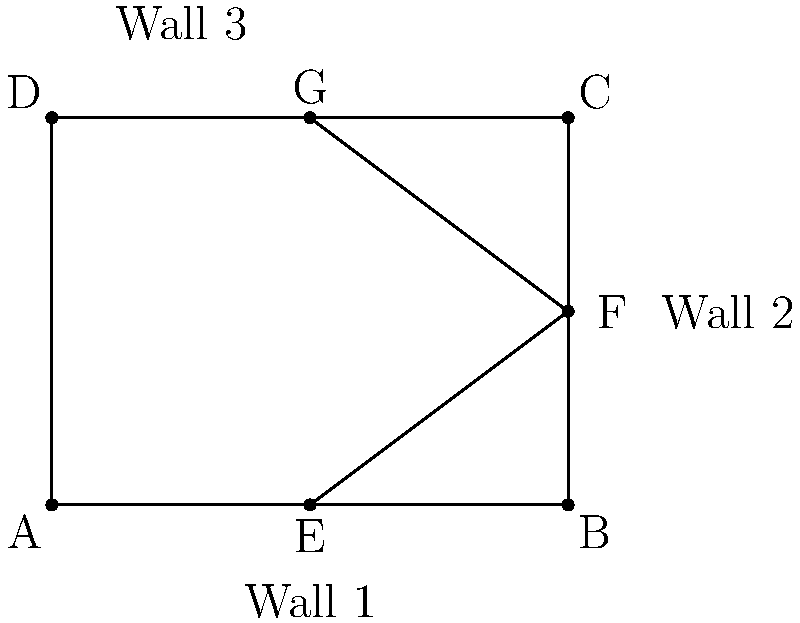During an excavation of an ancient city, you uncover the foundations of three city walls forming a right-angled structure. The diagram shows the layout of these walls. If $\overline{AE} \cong \overline{EG}$ and $\overline{BF} \cong \overline{FD}$, what is the length of $\overline{EF}$ in terms of $\overline{AB}$? Let's approach this step-by-step:

1) First, we notice that $\overline{AE} \cong \overline{EG}$. This means that E is the midpoint of $\overline{AG}$.

2) Since ABCD is a rectangle (as it represents the right-angled structure of the walls), we know that $\overline{AG}$ is a diagonal of this rectangle.

3) The diagonals of a rectangle bisect each other. Therefore, the point where $\overline{AG}$ and $\overline{BF}$ intersect is the midpoint of both diagonals.

4) We're told that $\overline{BF} \cong \overline{FD}$, which confirms that F is indeed the midpoint of $\overline{BD}$.

5) Now, let's consider triangle $\triangle{AEB}$. We know that:
   - $\angle{AEB}$ is a right angle (as it's in the corner of the rectangle)
   - $\overline{AE} = \frac{1}{2}\overline{AB}$ (as E is the midpoint of $\overline{AB}$)

6) This means that $\triangle{AEB}$ is a 30-60-90 triangle, where:
   - $\overline{AE} = \frac{1}{2}\overline{AB}$
   - $\overline{EB} = \frac{\sqrt{3}}{2}\overline{AB}$

7) Now, in $\triangle{EBF}$:
   - $\overline{EB} = \frac{\sqrt{3}}{2}\overline{AB}$
   - $\overline{BF} = \frac{1}{2}\overline{BC} = \frac{3}{8}\overline{AB}$ (as $\overline{BC} = \frac{3}{4}\overline{AB}$ in a 3-4-5 right triangle)

8) We can find $\overline{EF}$ using the Pythagorean theorem:

   $\overline{EF}^2 = \overline{EB}^2 + \overline{BF}^2$

   $\overline{EF}^2 = (\frac{\sqrt{3}}{2}\overline{AB})^2 + (\frac{3}{8}\overline{AB})^2$

   $\overline{EF}^2 = \frac{3}{4}\overline{AB}^2 + \frac{9}{64}\overline{AB}^2 = \frac{51}{64}\overline{AB}^2$

   $\overline{EF} = \frac{\sqrt{51}}{8}\overline{AB}$

Therefore, $\overline{EF} = \frac{\sqrt{51}}{8}\overline{AB}$.
Answer: $\frac{\sqrt{51}}{8}\overline{AB}$ 